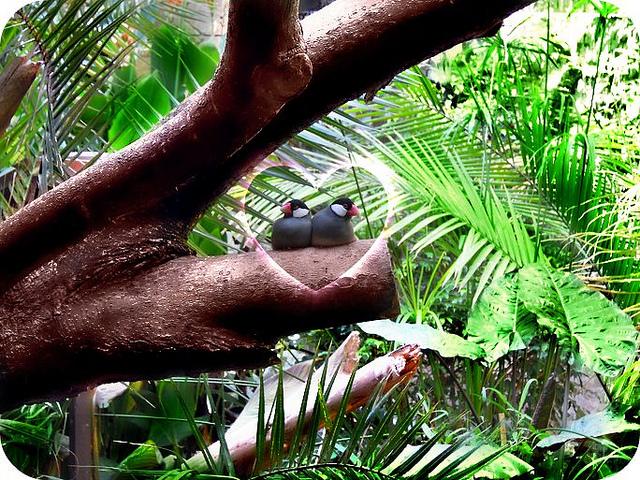Do these birds live in the jungle?
Short answer required. Yes. Are these love birds?
Write a very short answer. Yes. What photoshop technique was used in this shot?
Give a very brief answer. Heart. 